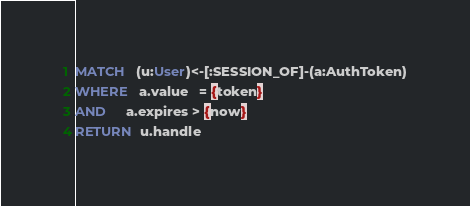<code> <loc_0><loc_0><loc_500><loc_500><_SQL_>MATCH   (u:User)<-[:SESSION_OF]-(a:AuthToken)
WHERE   a.value   = {token}
AND     a.expires > {now}
RETURN  u.handle
</code> 